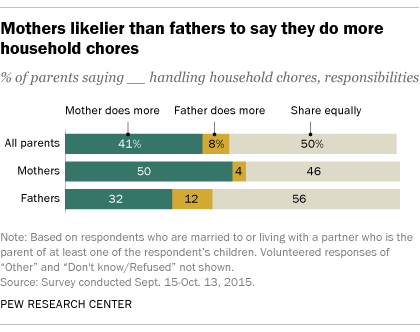Outline some significant characteristics in this image. Of the gray bar values that exceed 50, how many are 1? A small percentage of mothers report that the father does more household chores, with a value of 0.04%. 